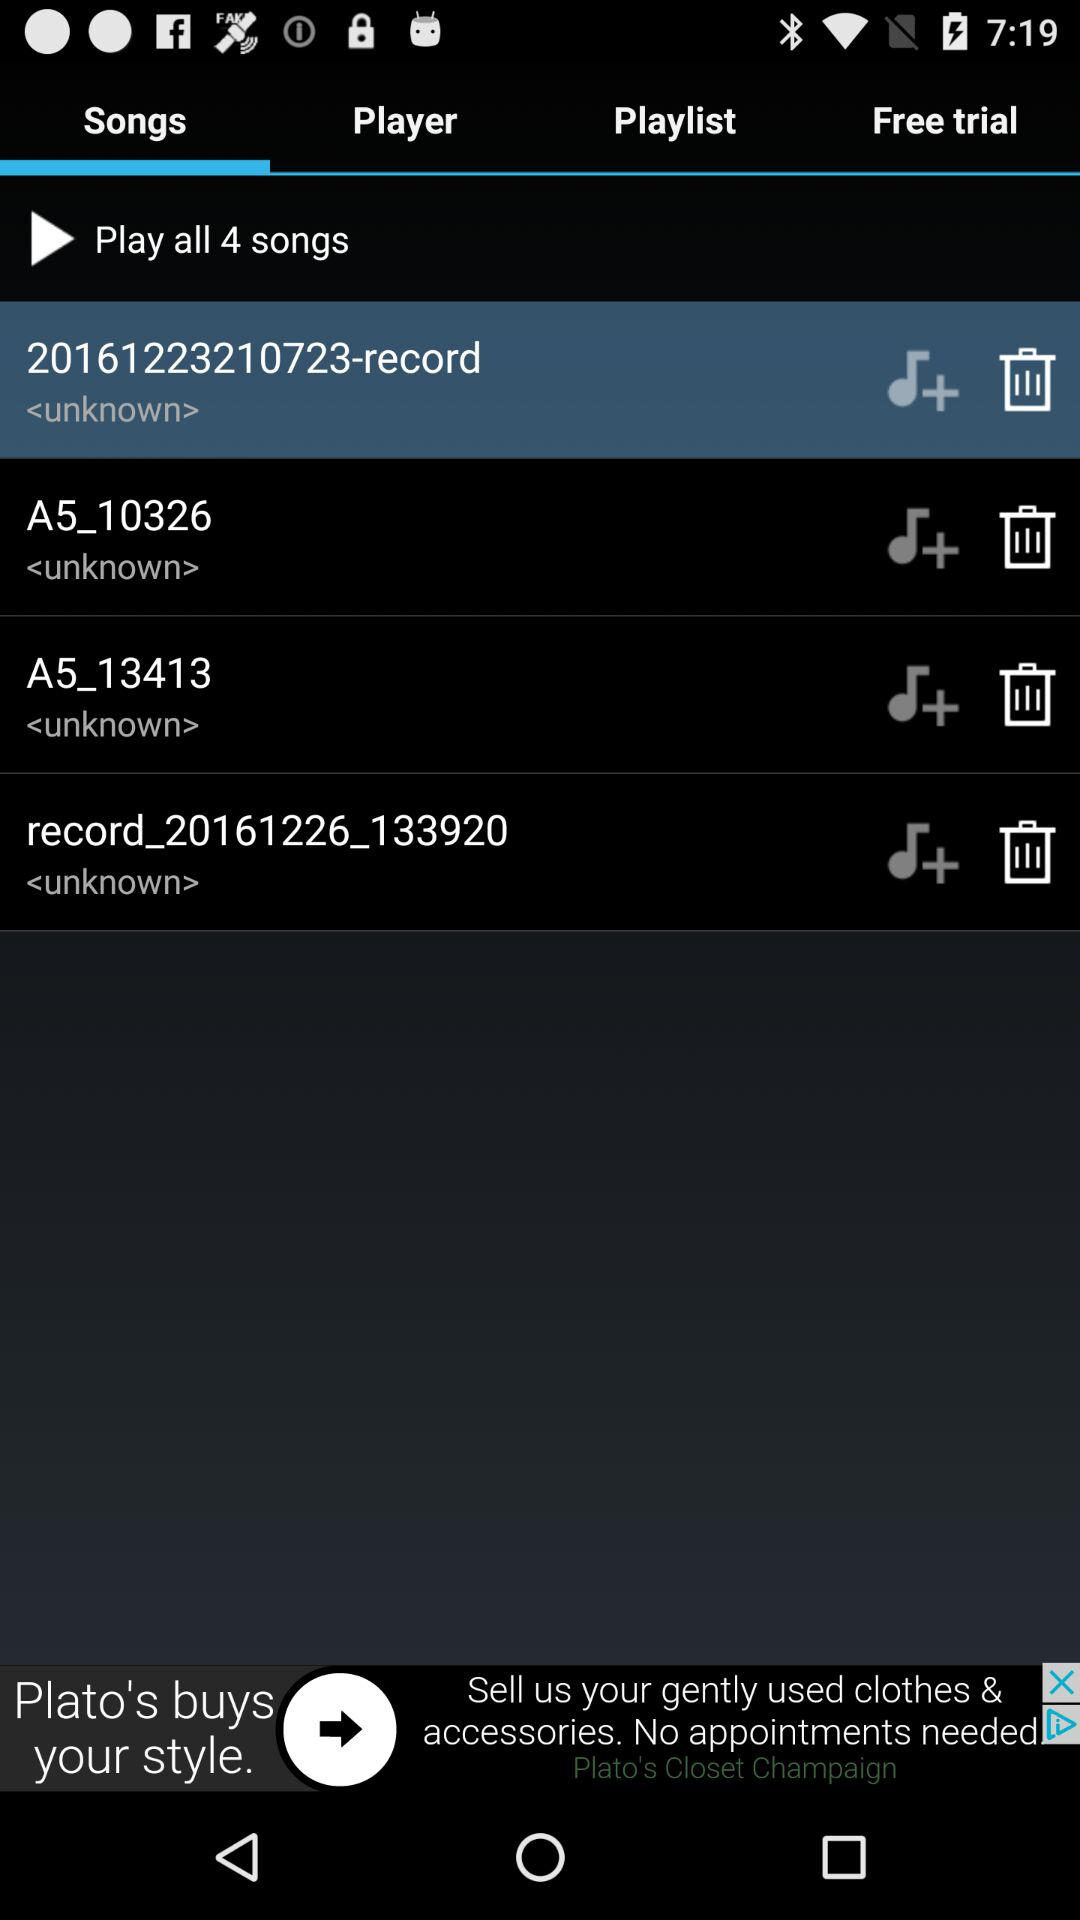Which song is selected? The selected song is "20161223210723-record". 